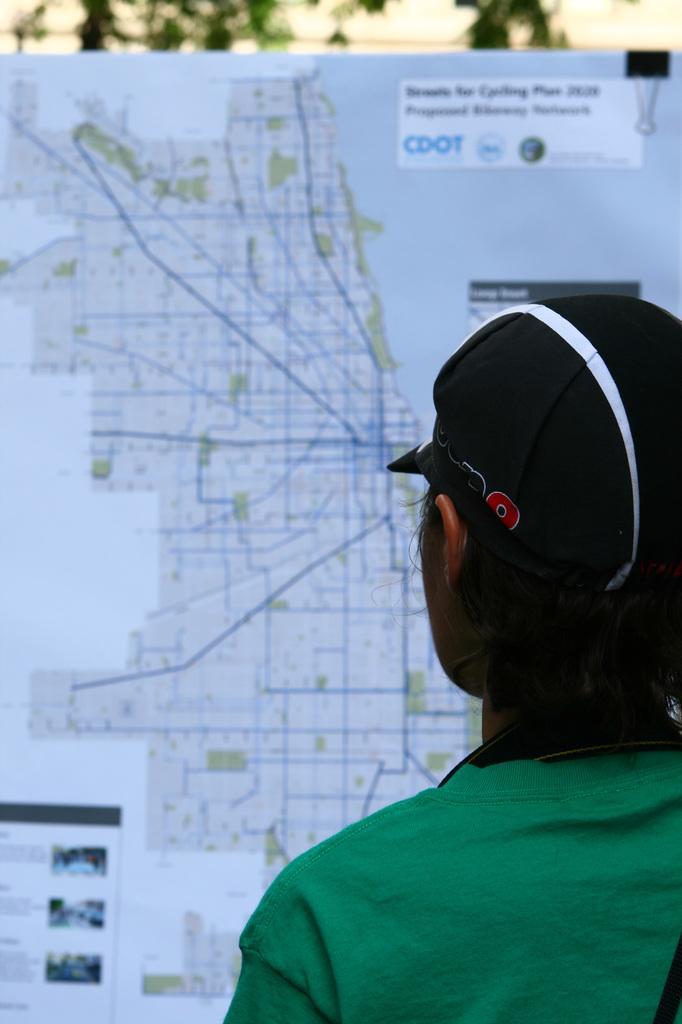In one or two sentences, can you explain what this image depicts? In this image we can see a person wearing the black color cap. In the background there is a board with the map and also the text. We can also see the trees in the background. 